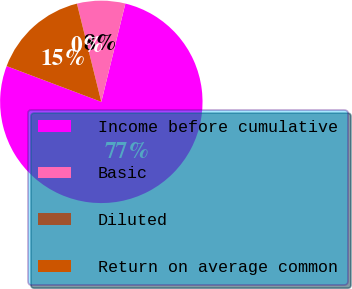<chart> <loc_0><loc_0><loc_500><loc_500><pie_chart><fcel>Income before cumulative<fcel>Basic<fcel>Diluted<fcel>Return on average common<nl><fcel>76.92%<fcel>7.69%<fcel>0.0%<fcel>15.38%<nl></chart> 